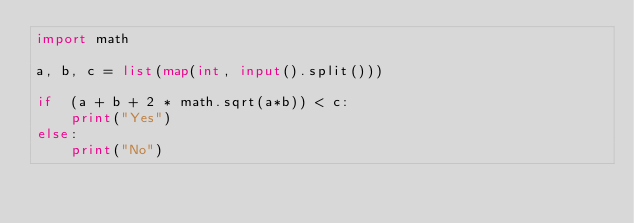Convert code to text. <code><loc_0><loc_0><loc_500><loc_500><_Python_>import math

a, b, c = list(map(int, input().split()))

if  (a + b + 2 * math.sqrt(a*b)) < c:
    print("Yes")
else:
    print("No")</code> 